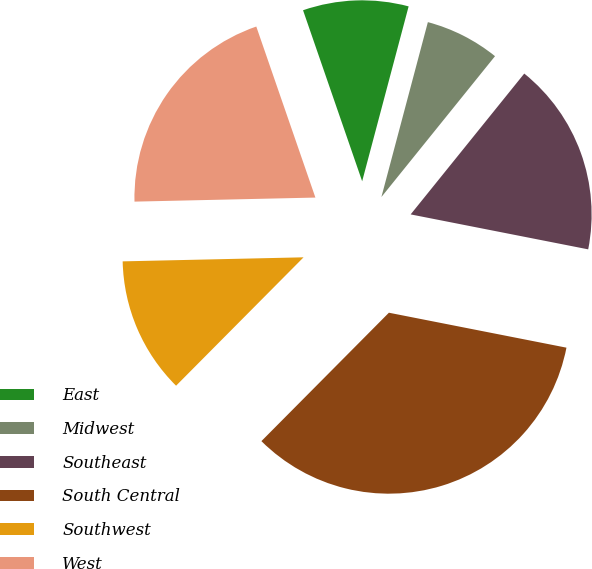<chart> <loc_0><loc_0><loc_500><loc_500><pie_chart><fcel>East<fcel>Midwest<fcel>Southeast<fcel>South Central<fcel>Southwest<fcel>West<nl><fcel>9.43%<fcel>6.67%<fcel>17.29%<fcel>34.35%<fcel>12.2%<fcel>20.06%<nl></chart> 